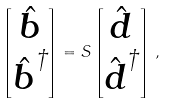<formula> <loc_0><loc_0><loc_500><loc_500>\begin{bmatrix} { \hat { \boldsymbol b } } \\ { \hat { \boldsymbol b } } ^ { \dagger } \end{bmatrix} = { S } \begin{bmatrix} { \hat { \boldsymbol d } } \\ { \hat { \boldsymbol d } } ^ { \dagger } \end{bmatrix} \, ,</formula> 